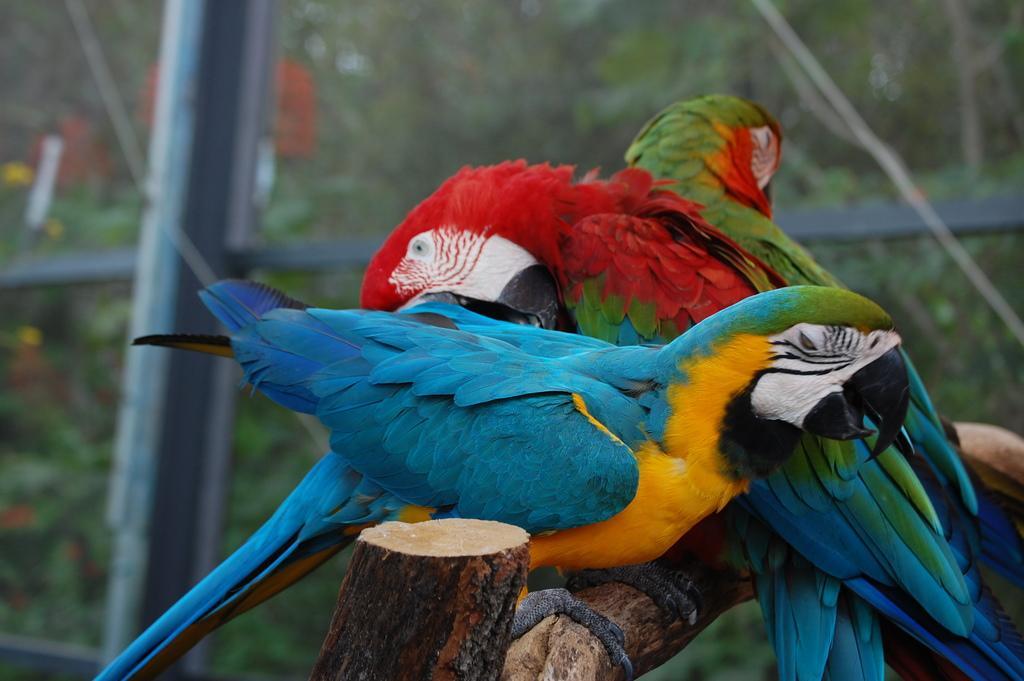Please provide a concise description of this image. In this image I can see three parrots on a branch. These parrots are in different colors. The background of the image is blurred. 